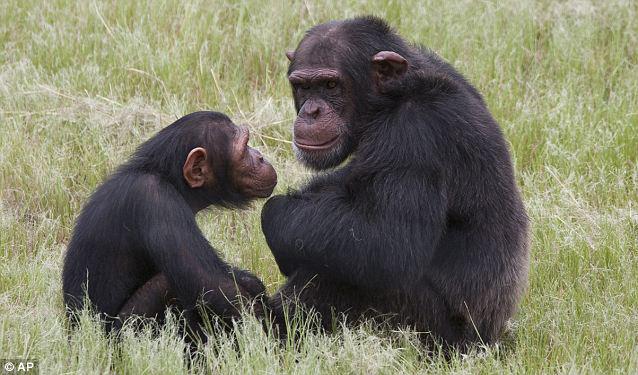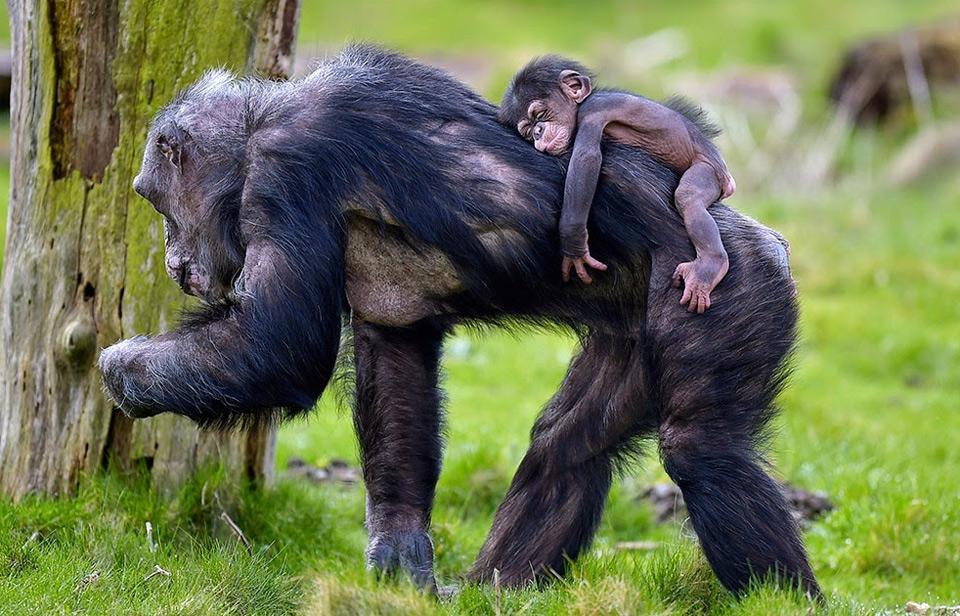The first image is the image on the left, the second image is the image on the right. Examine the images to the left and right. Is the description "A chimpanzee sleeps alone." accurate? Answer yes or no. No. The first image is the image on the left, the second image is the image on the right. Evaluate the accuracy of this statement regarding the images: "The left image has at least one chimp lying down.". Is it true? Answer yes or no. No. 